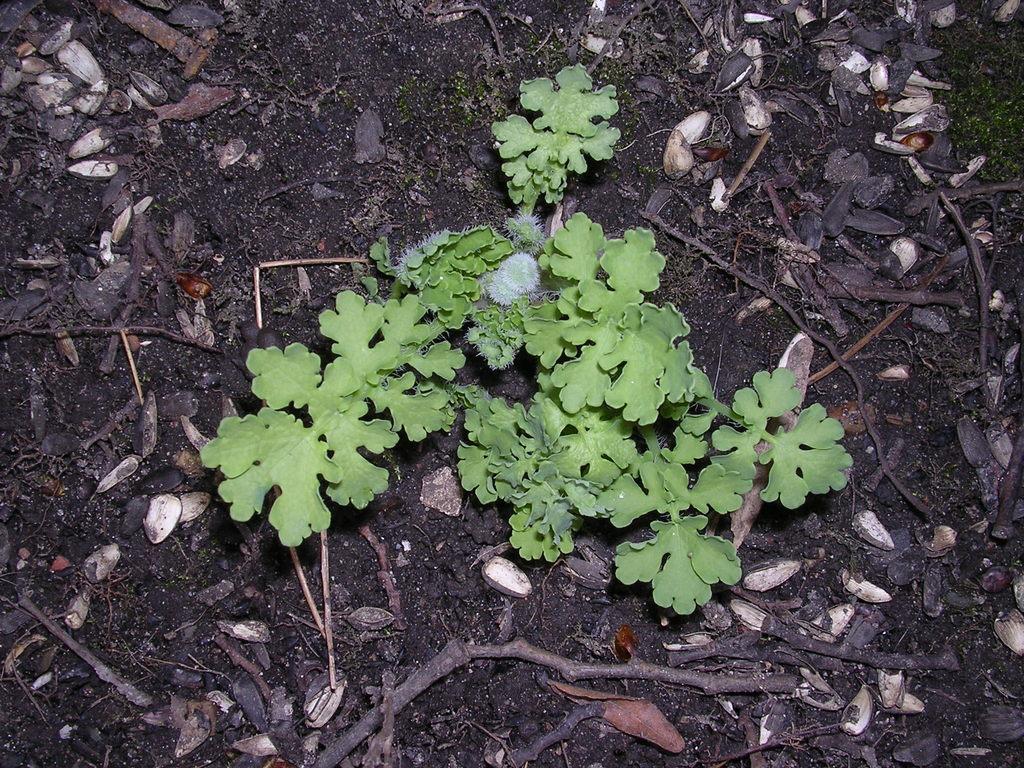Could you give a brief overview of what you see in this image? In this image I can see green colour leaves and I can also see sticks on ground. 